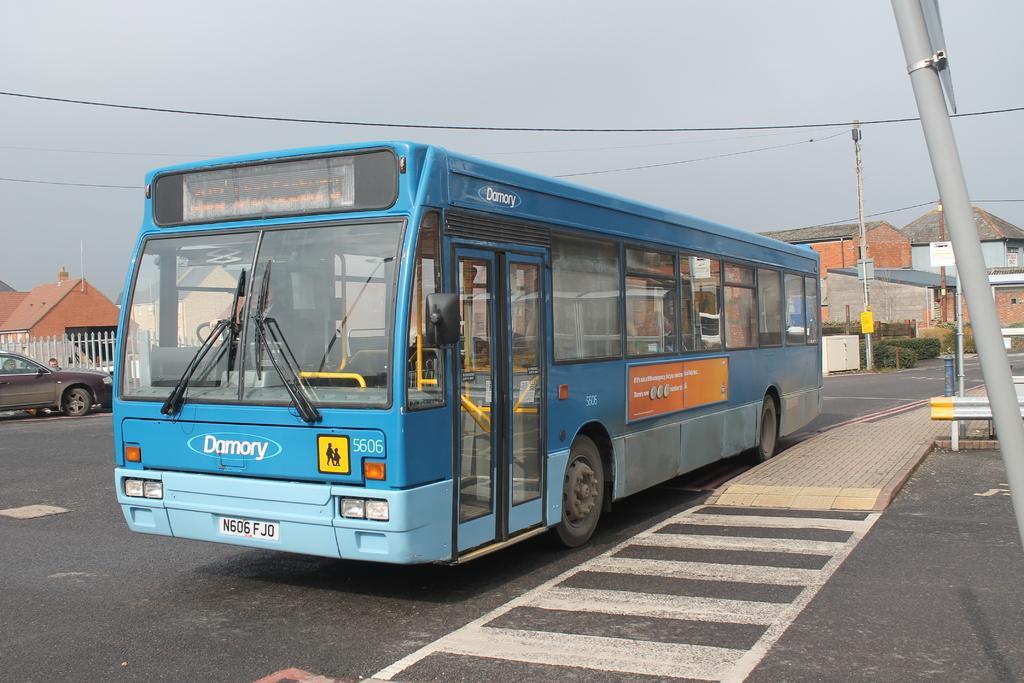Could you give a brief overview of what you see in this image? In this picture there is a bus and car on the road. At the back there buildings, trees and poles. On the right side of the image there are poles and there are wires on the poles and there is a railing. At the top there is sky. At the bottom there is a road. 